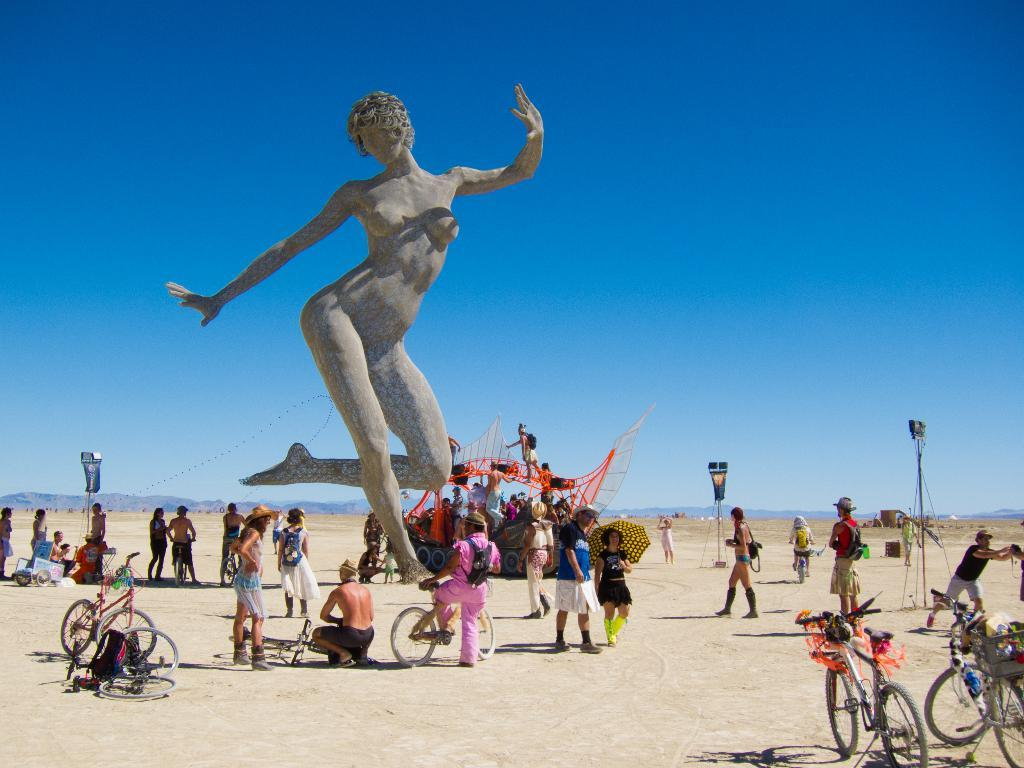What is the main subject in the middle of the image? There is a sculpture in the middle of the image. What can be seen at the bottom of the image? There are many people, bicycles, a vehicle, lights, and land visible at the bottom of the image. What is the background of the image like? The background of the image features hills and the sky. Can you see any cords attached to the sculpture in the image? There are no cords visible in the image; the focus is on the sculpture itself and its surroundings. How many clams are present in the image? There are no clams present in the image; the focus is on the sculpture, people, and other elements mentioned in the facts. 